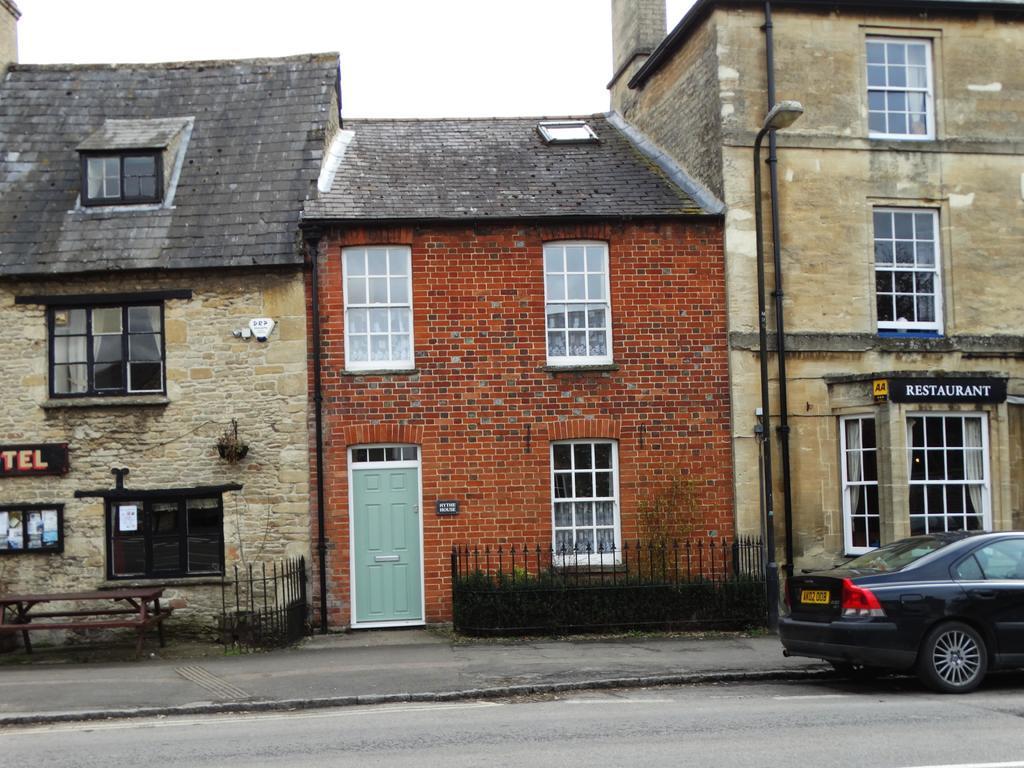Describe this image in one or two sentences. There are some houses and there is a car in front of the house. 